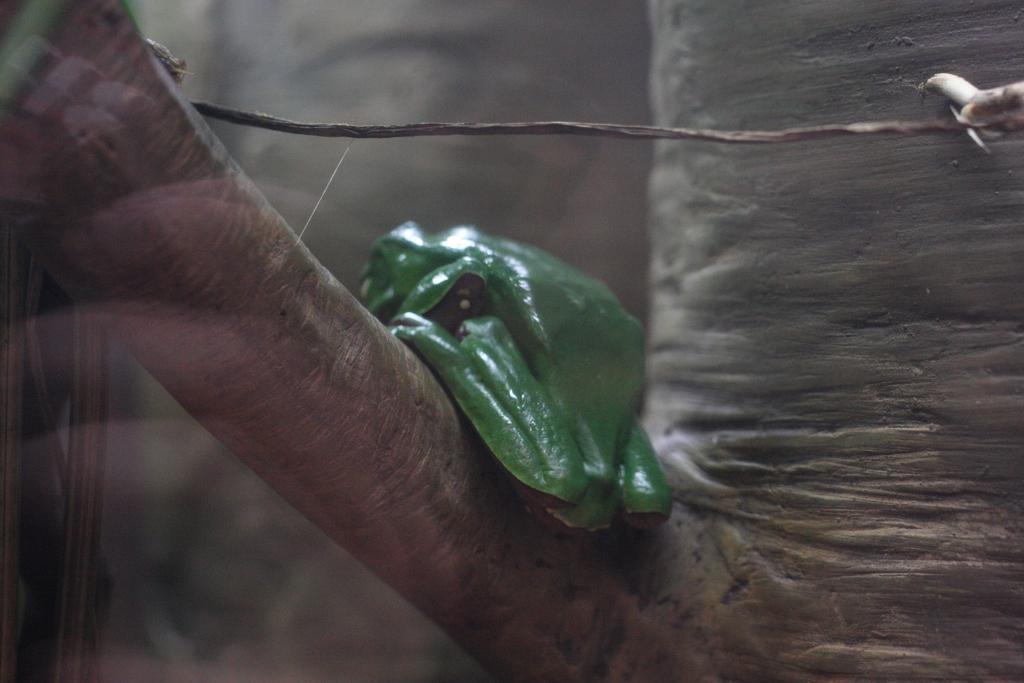How would you summarize this image in a sentence or two? In the center of the image there is a frog on the tree. 